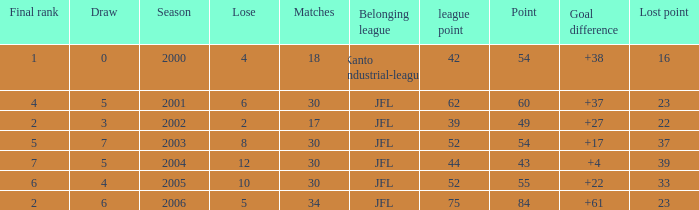I want the total number of matches for draw less than 7 and lost point of 16 with lose more than 4 0.0. 